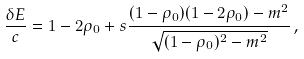Convert formula to latex. <formula><loc_0><loc_0><loc_500><loc_500>\frac { \delta E } { c } = 1 - 2 \rho _ { 0 } + s \frac { ( 1 - \rho _ { 0 } ) ( 1 - 2 \rho _ { 0 } ) - m ^ { 2 } } { \sqrt { ( 1 - \rho _ { 0 } ) ^ { 2 } - m ^ { 2 } } } \, ,</formula> 